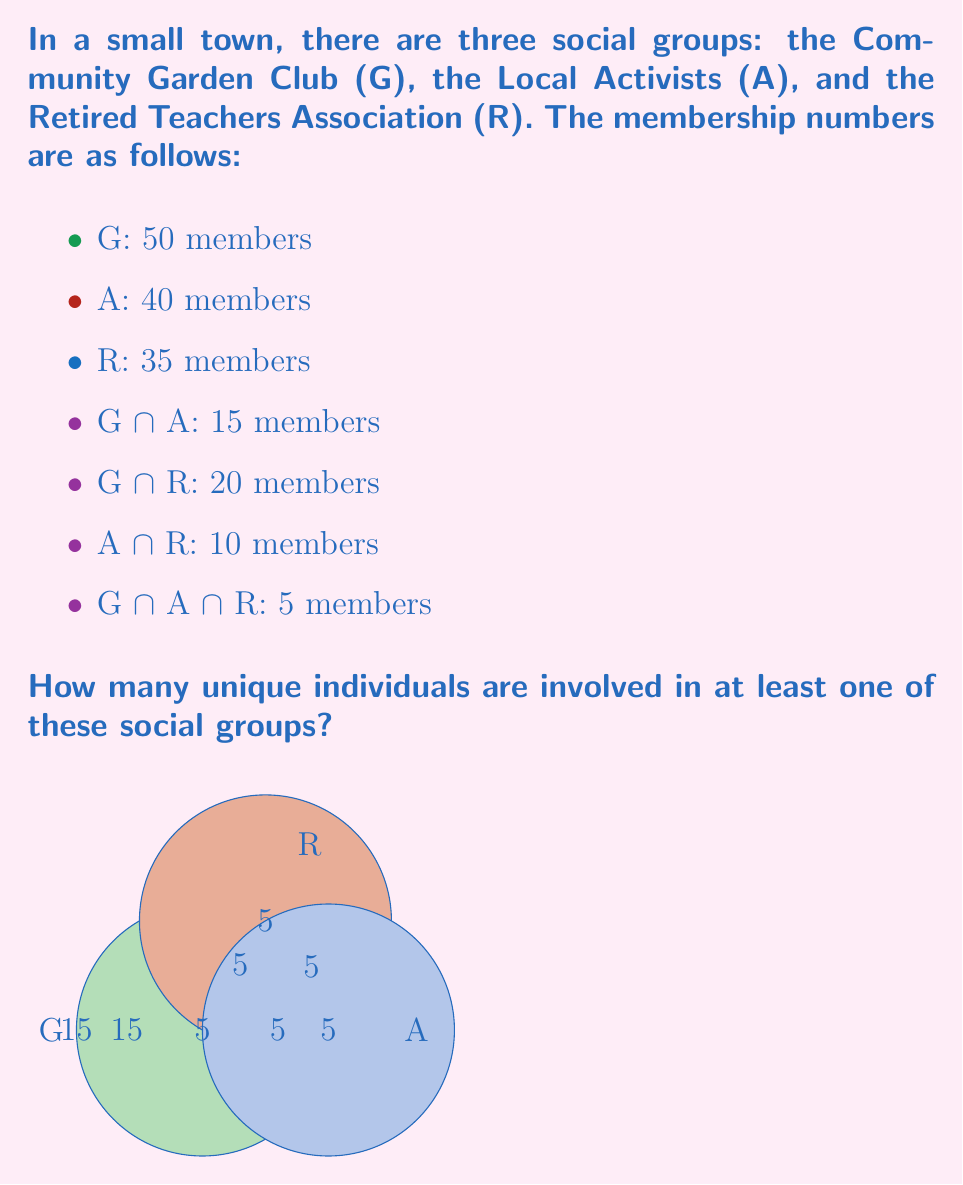Solve this math problem. To solve this problem, we'll use the principle of inclusion-exclusion for three sets. Let's follow these steps:

1) First, we need to find $|G \cup A \cup R|$, which represents the total number of unique individuals.

2) The formula for three sets is:
   $$|G \cup A \cup R| = |G| + |A| + |R| - |G \cap A| - |G \cap R| - |A \cap R| + |G \cap A \cap R|$$

3) Let's substitute the given values:
   $$|G \cup A \cup R| = 50 + 40 + 35 - 15 - 20 - 10 + 5$$

4) Now, let's calculate:
   $$|G \cup A \cup R| = 125 - 45 + 5 = 85$$

5) Therefore, the number of unique individuals involved in at least one of these social groups is 85.

This solution considers all members of each group, subtracts those counted twice in the intersections of two groups, and then adds back those counted three times in the intersection of all three groups.
Answer: 85 